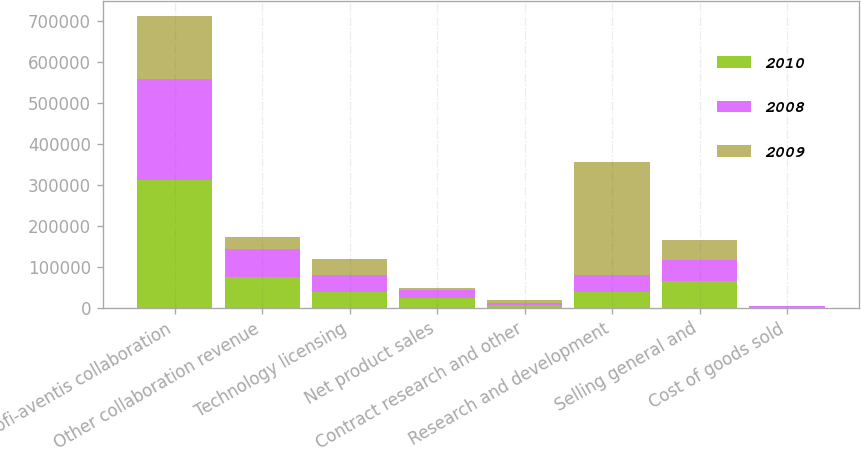<chart> <loc_0><loc_0><loc_500><loc_500><stacked_bar_chart><ecel><fcel>Sanofi-aventis collaboration<fcel>Other collaboration revenue<fcel>Technology licensing<fcel>Net product sales<fcel>Contract research and other<fcel>Research and development<fcel>Selling general and<fcel>Cost of goods sold<nl><fcel>2010<fcel>311332<fcel>75393<fcel>40150<fcel>25254<fcel>6945<fcel>40006.5<fcel>65201<fcel>2093<nl><fcel>2008<fcel>247140<fcel>67317<fcel>40013<fcel>18364<fcel>6434<fcel>40006.5<fcel>52923<fcel>1686<nl><fcel>2009<fcel>153972<fcel>31166<fcel>40000<fcel>6249<fcel>7070<fcel>274903<fcel>48880<fcel>923<nl></chart> 